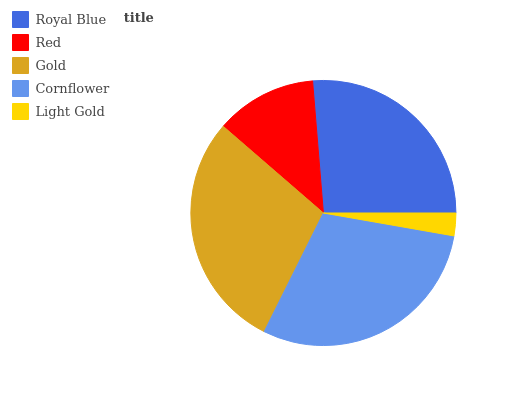Is Light Gold the minimum?
Answer yes or no. Yes. Is Cornflower the maximum?
Answer yes or no. Yes. Is Red the minimum?
Answer yes or no. No. Is Red the maximum?
Answer yes or no. No. Is Royal Blue greater than Red?
Answer yes or no. Yes. Is Red less than Royal Blue?
Answer yes or no. Yes. Is Red greater than Royal Blue?
Answer yes or no. No. Is Royal Blue less than Red?
Answer yes or no. No. Is Royal Blue the high median?
Answer yes or no. Yes. Is Royal Blue the low median?
Answer yes or no. Yes. Is Gold the high median?
Answer yes or no. No. Is Gold the low median?
Answer yes or no. No. 